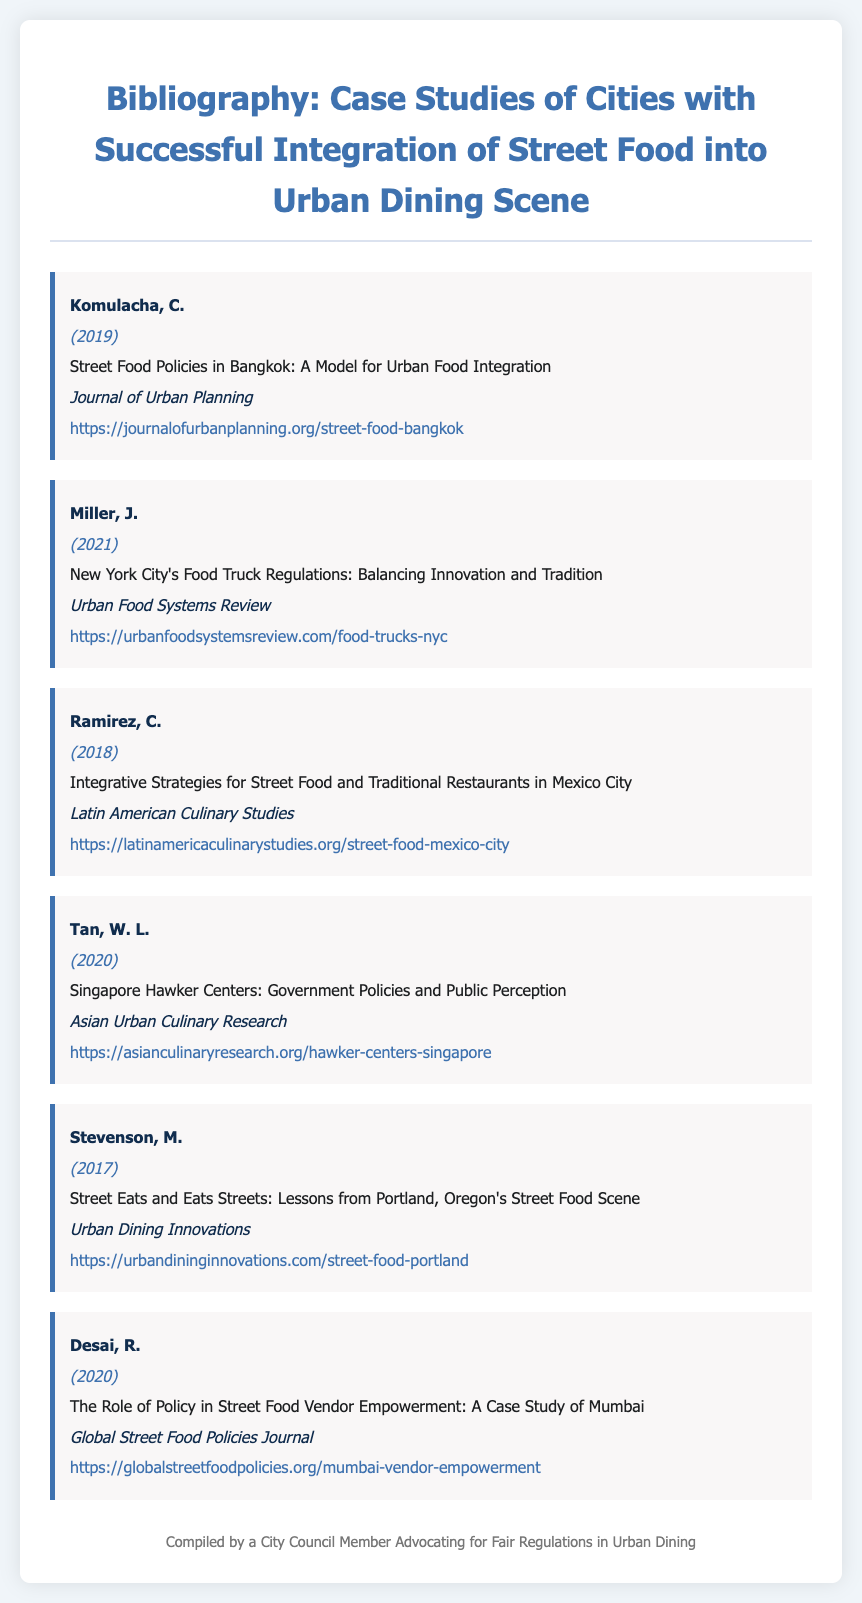What is the title of the first bibliography item? The first bibliography item's title is listed directly in the document.
Answer: Street Food Policies in Bangkok: A Model for Urban Food Integration Who is the author of the second bibliography item? The author of the second bibliography item can be found in the document under the respective title.
Answer: Miller, J In what year was the last bibliography item published? The publication year of the last bibliography item is presented in the document next to the author's name.
Answer: 2020 What is the source of the article by Tan, W. L.? The source is indicated in the bibliography item associated with Tan, W. L.'s title.
Answer: Asian Urban Culinary Research How many total bibliography items are listed in the document? The total number of items can be counted from the list provided in the document.
Answer: 6 Which city is specifically mentioned in the title of Ramirez's article? The city mentioned is found in the title of the respective bibliography item.
Answer: Mexico City What is the main focus of the article by Desai, R.? The focus of Desai, R.'s article is outlined in the title of the bibliography item.
Answer: Vendor Empowerment What type of document is this? The type of document is indicated in the title at the top of the page.
Answer: Bibliography 